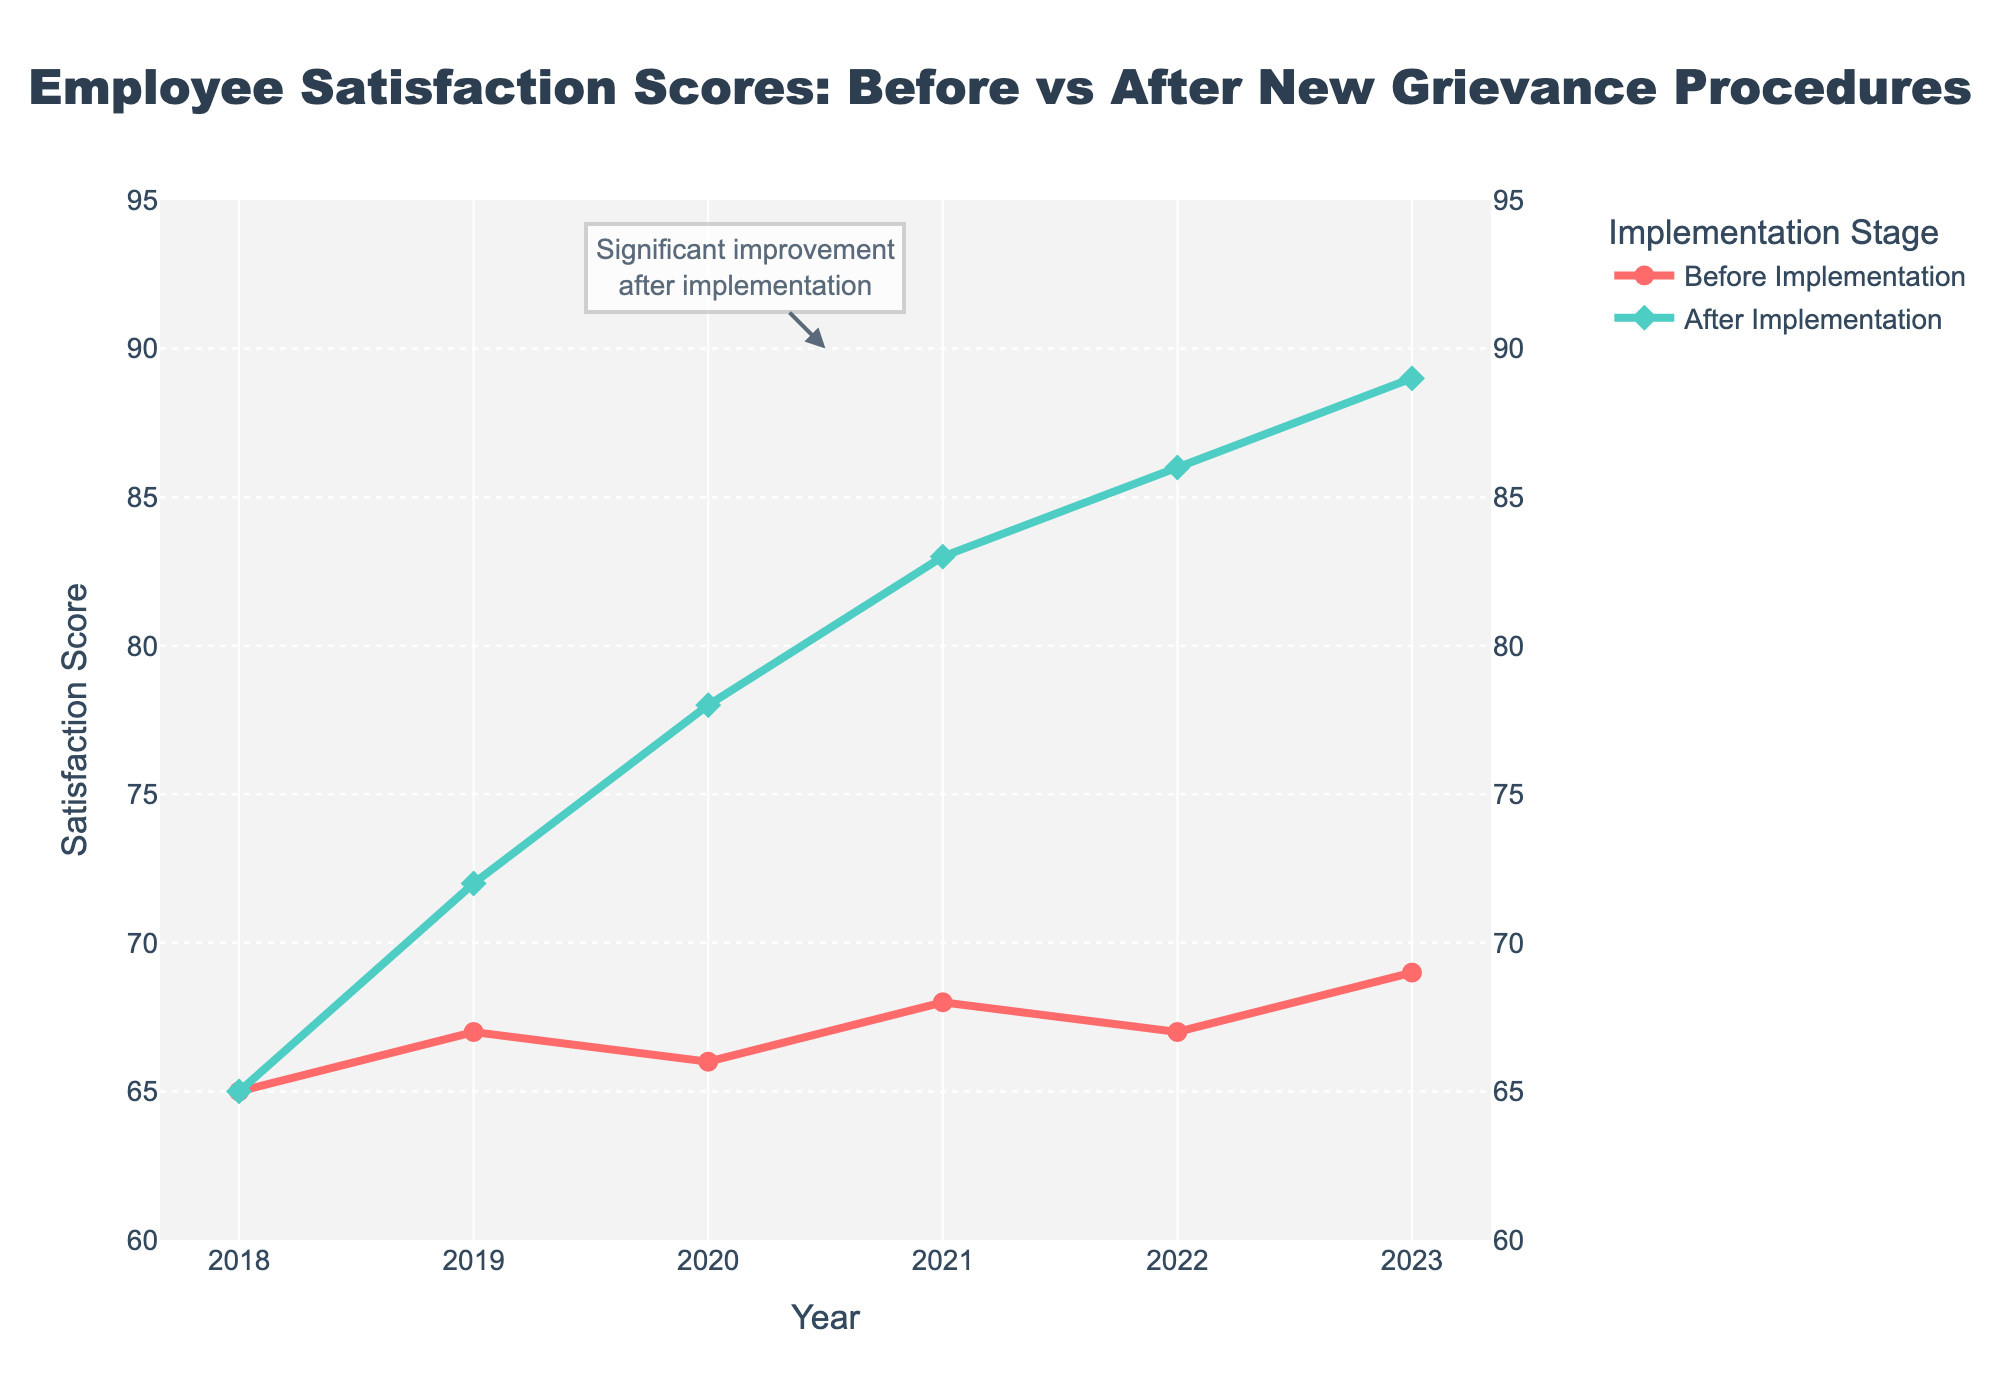What's the highest employee satisfaction score after implementing the new grievance procedures? To find the highest score, look at the "After Implementation" line. The highest point on this line is in 2023, where the satisfaction score is 89.
Answer: 89 What's the lowest employee satisfaction score before implementing the new grievance procedures? To find the lowest score before implementation, examine the "Before Implementation" line. The lowest point on this line is in 2018, where the score is 65.
Answer: 65 By how much did employee satisfaction scores improve from the initial year (2018) to the final year (2023) after the new grievance procedures were implemented? For "After Implementation," the scores improved from 65 in 2018 to 89 in 2023. The improvement can be calculated as 89 - 65 = 24.
Answer: 24 In which year did the employee satisfaction score after implementation surpass the score before implementation? Look at the "After Implementation" and "Before Implementation" lines. In 2019, the "After Implementation" score (72) surpassed the "Before Implementation" score (67).
Answer: 2019 What's the average employee satisfaction score before implementing the new grievance procedures? Find the average of the "Before Implementation" scores: (65 + 67 + 66 + 68 + 67 + 69) / 6 = 402 / 6 = 67.
Answer: 67 What's the difference between the employee satisfaction scores before and after implementation in 2022? Compare the "Before Implementation" score (67) and "After Implementation" score (86) for 2022. The difference is 86 - 67 = 19.
Answer: 19 What visual attribute indicates significant improvement after implementing new grievance procedures? The annotation near the center of the "After Implementation" line, along with the stepwise increase in the green line, highlights the significant improvement after new procedures were introduced.
Answer: Annotation and green line increase 